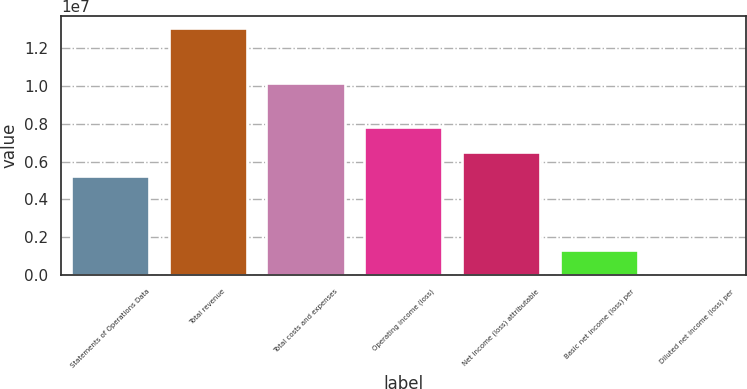<chart> <loc_0><loc_0><loc_500><loc_500><bar_chart><fcel>Statements of Operations Data<fcel>Total revenue<fcel>Total costs and expenses<fcel>Operating income (loss)<fcel>Net income (loss) attributable<fcel>Basic net income (loss) per<fcel>Diluted net income (loss) per<nl><fcel>5.22963e+06<fcel>1.30741e+07<fcel>1.01451e+07<fcel>7.84444e+06<fcel>6.53703e+06<fcel>1.30741e+06<fcel>3.39<nl></chart> 